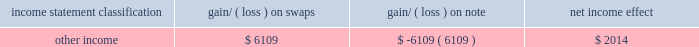As of october 31 , 2009 , the total notional amount of these undesignated hedges was $ 38 million .
The fair value of these hedging instruments in the company 2019s condensed consolidated balance sheet as of october 31 , 2009 was immaterial .
Interest rate exposure management 2014 on june 30 , 2009 , the company entered into interest rate swap transactions related to its outstanding notes where the company swapped the notional amount of its $ 375 million of fixed rate debt at 5.0% ( 5.0 % ) into floating interest rate debt through july 1 , 2014 .
Under the terms of the swaps , the company will ( i ) receive on the $ 375 million notional amount a 5.0% ( 5.0 % ) annual interest payment that is paid in two installments on the 1st of every january and july , commencing january 1 , 2010 through and ending on the maturity date ; and ( ii ) pay on the $ 375 million notional amount an annual three-month libor plus 2.05% ( 2.05 % ) ( 2.34% ( 2.34 % ) as of october 31 , 2009 ) interest payment , payable in four installments on the 1st of every january , april , july and october , commencing on october 1 , 2009 and ending on the maturity date .
The libor based rate is set quarterly three months prior to the date of the interest payment .
The company designated these swaps as fair value hedges .
The fair value of the swaps at inception were zero and subsequent changes in the fair value of the interest rate swaps were reflected in the carrying value of the interest rate swaps on the balance sheet .
The carrying value of the debt on the balance sheet was adjusted by an equal and offsetting amount .
The gain or loss on the hedged item ( that is fixed- rate borrowings ) attributable to the hedged benchmark interest rate risk and the offsetting gain or loss on the related interest rate swaps as of october 31 , 2009 is as follows : income statement classification gain/ ( loss ) on gain/ ( loss ) on note net income effect .
The amounts earned and owed under the swap agreements are accrued each period and are reported in interest expense .
There was no ineffectiveness recognized in any of the periods presented .
The market risk associated with the company 2019s derivative instruments results from currency exchange rate or interest rate movements that are expected to offset the market risk of the underlying transactions , assets and liabilities being hedged .
The counterparties to the agreements relating to the company 2019s derivative instruments consist of a number of major international financial institutions with high credit ratings .
The company does not believe that there is significant risk of nonperformance by these counterparties because the company continually monitors the credit ratings of such counterparties .
Furthermore , none of the company 2019s derivative transactions are subject to collateral or other security arrangements and none contain provisions that are dependent on the company 2019s credit ratings from any credit rating agency .
While the contract or notional amounts of derivative financial instruments provide one measure of the volume of these transactions , they do not represent the amount of the company 2019s exposure to credit risk .
The amounts potentially subject to credit risk ( arising from the possible inability of counterparties to meet the terms of their contracts ) are generally limited to the amounts , if any , by which the counterparties 2019 obligations under the contracts exceed the obligations of the company to the counterparties .
As a result of the above considerations , the company does not consider the risk of counterparty default to be significant .
The company records the fair value of its derivative financial instruments in the consolidated financial statements in other current assets , other assets or accrued liabilities , depending on their net position , regardless of the purpose or intent for holding the derivative contract .
Changes in the fair value of the derivative financial instruments are either recognized periodically in earnings or in shareholders 2019 equity as a component of oci .
Changes in the fair value of cash flow hedges are recorded in oci and reclassified into earnings when the underlying contract matures .
Changes in the fair values of derivatives not qualifying for hedge accounting are reported in earnings as they occur .
The total notional amount of derivative instruments designated as hedging instruments as of october 31 , 2009 is as follows : $ 375 million of interest rate swap agreements accounted as fair value hedges , and $ 128.0 million of analog devices , inc .
Notes to consolidated financial statements 2014 ( continued ) .
What is the net difference between in amounts used to as hedging instruments? 
Computations: (375 - 128.0)
Answer: 247.0. 